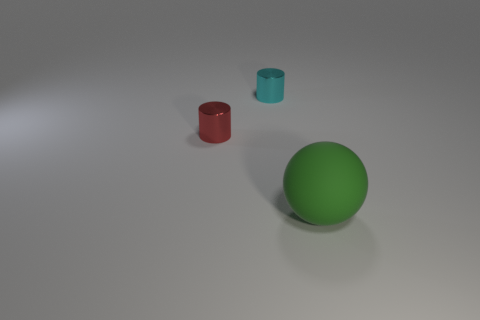What is the shape of the tiny shiny thing in front of the small metallic object behind the red thing?
Ensure brevity in your answer.  Cylinder. What number of small objects are shiny objects or cyan metal cylinders?
Offer a very short reply. 2. How many other big matte things have the same shape as the green rubber thing?
Your response must be concise. 0. Does the red metal thing have the same shape as the green rubber thing in front of the cyan cylinder?
Keep it short and to the point. No. What number of red objects are behind the green thing?
Give a very brief answer. 1. Are there any cyan cylinders of the same size as the cyan metallic thing?
Give a very brief answer. No. Is the shape of the tiny thing left of the tiny cyan shiny cylinder the same as  the big object?
Offer a terse response. No. What is the color of the large matte thing?
Provide a succinct answer. Green. Is there a big blue metallic cube?
Keep it short and to the point. No. The thing that is made of the same material as the tiny cyan cylinder is what size?
Provide a short and direct response. Small. 